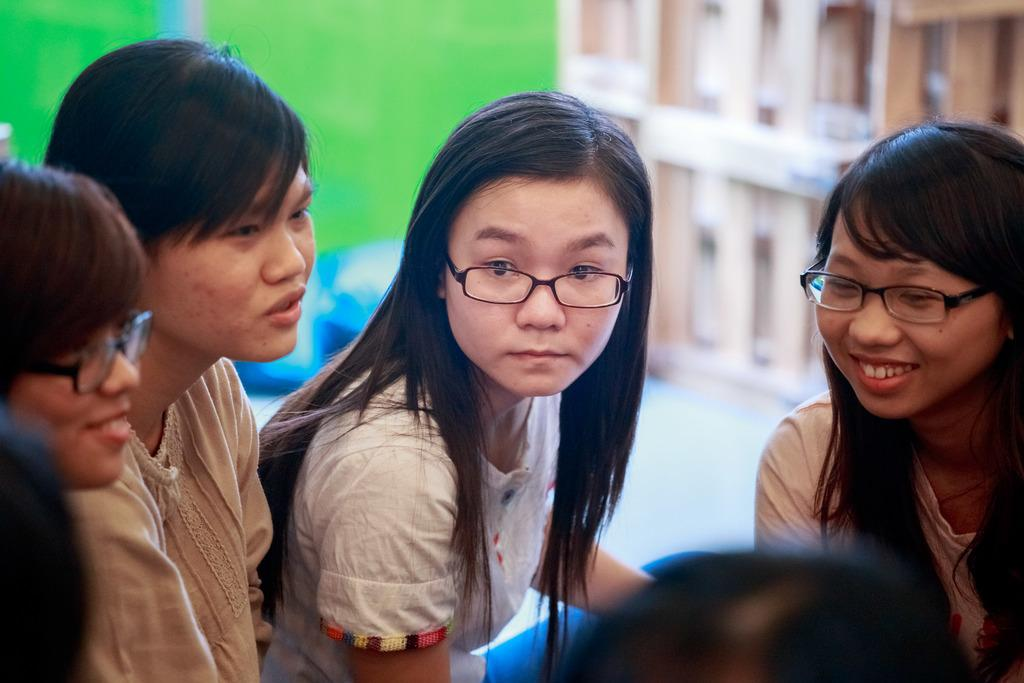What is the main subject of the image? The main subject of the image is a group of girls. Where are the girls located in the image? The girls are gathered in the front of the image. Can you describe the background of the image? The background of the image is blurred. What historical event is depicted in the image involving a cub and a slave? There is no historical event, cub, or slave depicted in the image; it features a group of girls gathered in the front. 